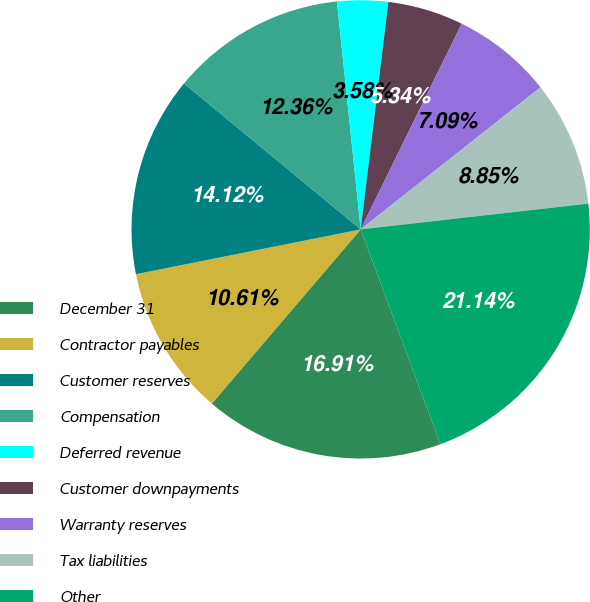Convert chart. <chart><loc_0><loc_0><loc_500><loc_500><pie_chart><fcel>December 31<fcel>Contractor payables<fcel>Customer reserves<fcel>Compensation<fcel>Deferred revenue<fcel>Customer downpayments<fcel>Warranty reserves<fcel>Tax liabilities<fcel>Other<nl><fcel>16.91%<fcel>10.61%<fcel>14.12%<fcel>12.36%<fcel>3.58%<fcel>5.34%<fcel>7.09%<fcel>8.85%<fcel>21.14%<nl></chart> 